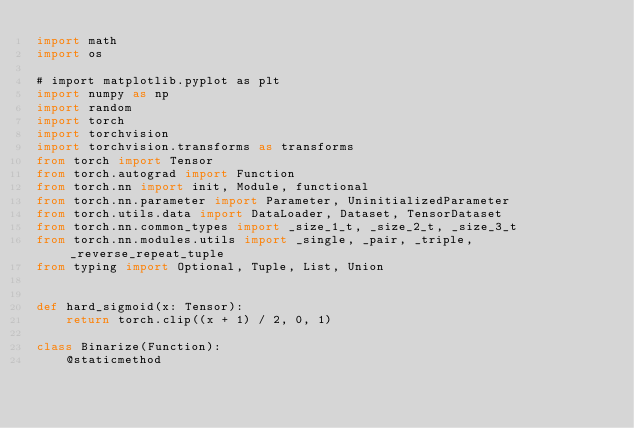<code> <loc_0><loc_0><loc_500><loc_500><_Python_>import math
import os

# import matplotlib.pyplot as plt
import numpy as np
import random
import torch
import torchvision
import torchvision.transforms as transforms
from torch import Tensor
from torch.autograd import Function
from torch.nn import init, Module, functional
from torch.nn.parameter import Parameter, UninitializedParameter
from torch.utils.data import DataLoader, Dataset, TensorDataset
from torch.nn.common_types import _size_1_t, _size_2_t, _size_3_t
from torch.nn.modules.utils import _single, _pair, _triple, _reverse_repeat_tuple
from typing import Optional, Tuple, List, Union


def hard_sigmoid(x: Tensor):
    return torch.clip((x + 1) / 2, 0, 1)

class Binarize(Function):
    @staticmethod</code> 